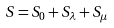Convert formula to latex. <formula><loc_0><loc_0><loc_500><loc_500>S = S _ { 0 } + S _ { \lambda } + S _ { \mu }</formula> 